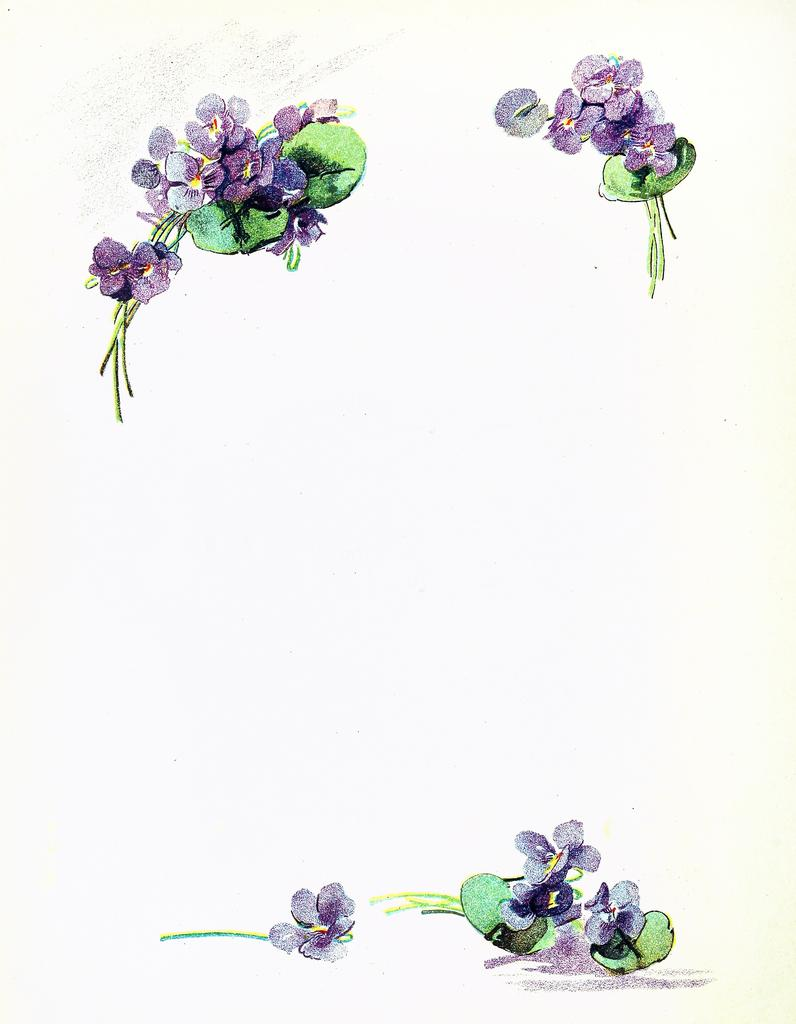What type of material is the image made of? The image appears to be a paper. What is depicted on the paper? There are printed flowers and leaves on the paper. What is the profit margin of the giraffe in the image? There is no giraffe present in the image, and therefore no profit margin can be determined. 